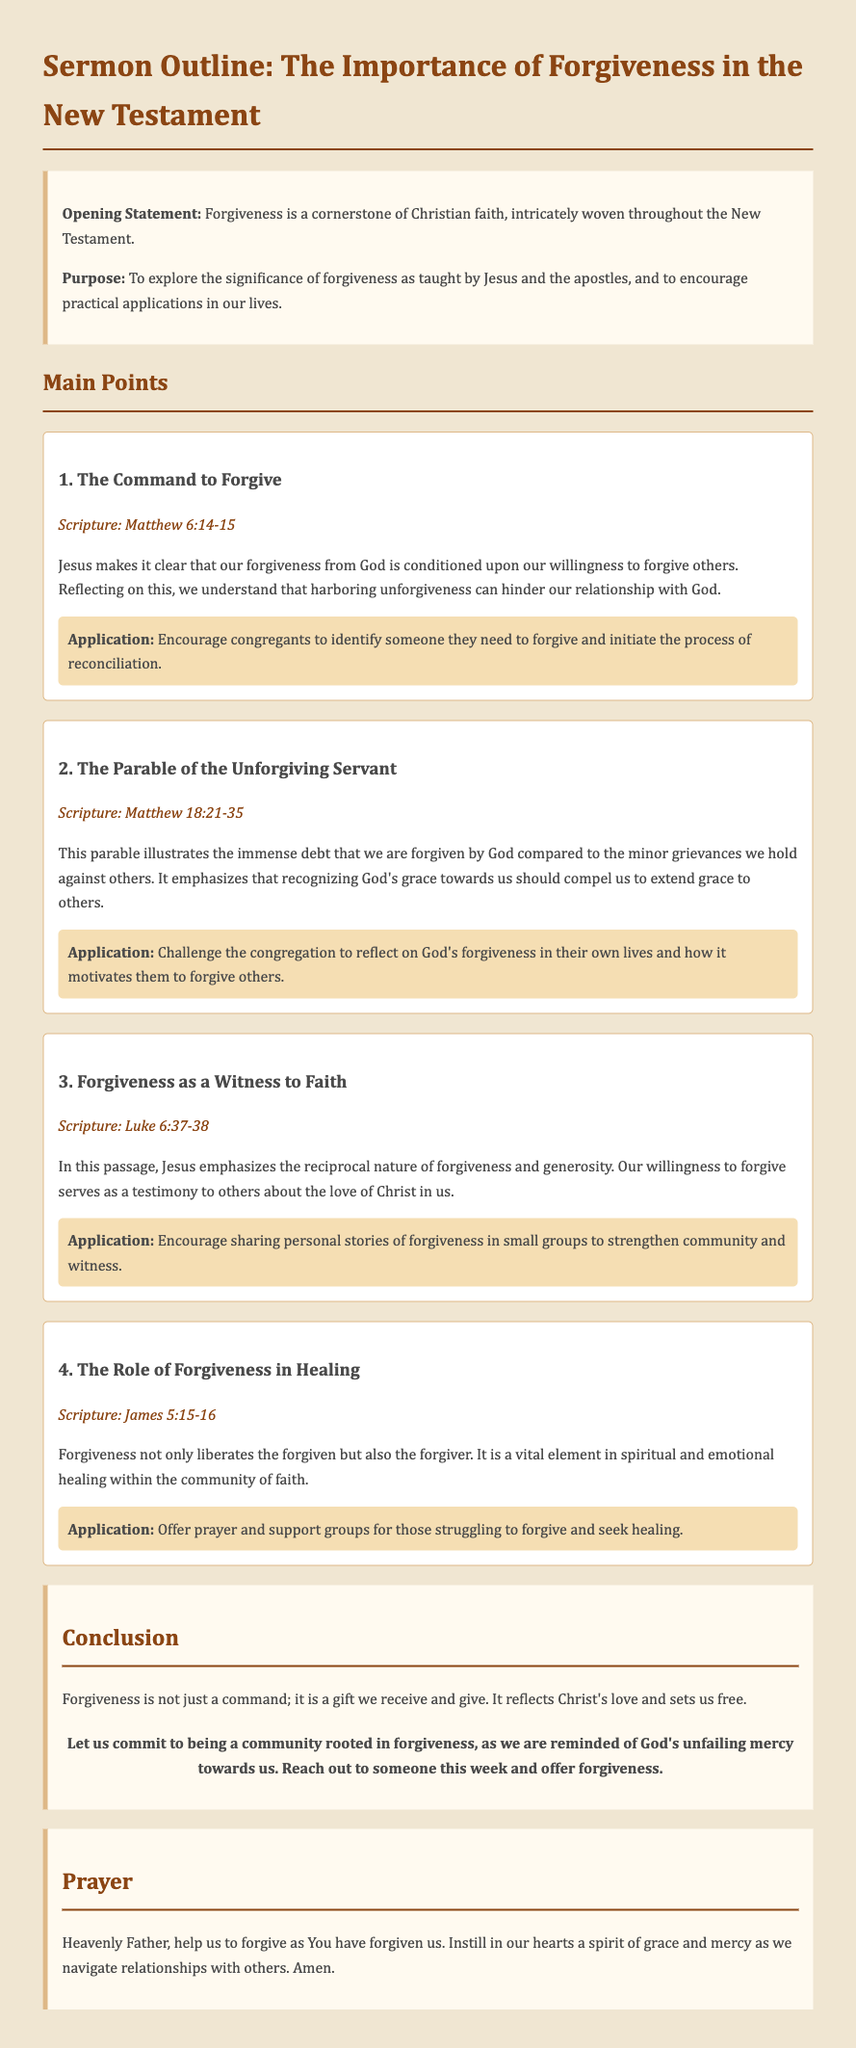what is the title of the sermon outline? The title of the sermon outline is provided in the document as the first text and states the focus of the content.
Answer: The Importance of Forgiveness in the New Testament how many main points are presented in the sermon outline? The number of main points is indicated in the document following the section heading "Main Points."
Answer: Four which scripture is referenced regarding the command to forgive? The specific scripture reference is listed under the first main point, denoting its source in the New Testament.
Answer: Matthew 6:14-15 what is the application for the parable of the unforgiving servant? The recommended application is included in the second main point, suggesting a reflective action for the congregation.
Answer: Challenge the congregation to reflect on God's forgiveness in their own lives and how it motivates them to forgive others what does the conclusion state about forgiveness? The conclusion summarizes the sermon’s message regarding forgiveness, emphasizing its importance in Christian faith.
Answer: Forgiveness is not just a command; it is a gift we receive and give how does Jesus relate forgiveness to generosity? This relationship is conveyed in a scripture that highlights the mutual effects of our actions regarding forgiveness and generosity.
Answer: Luke 6:37-38 